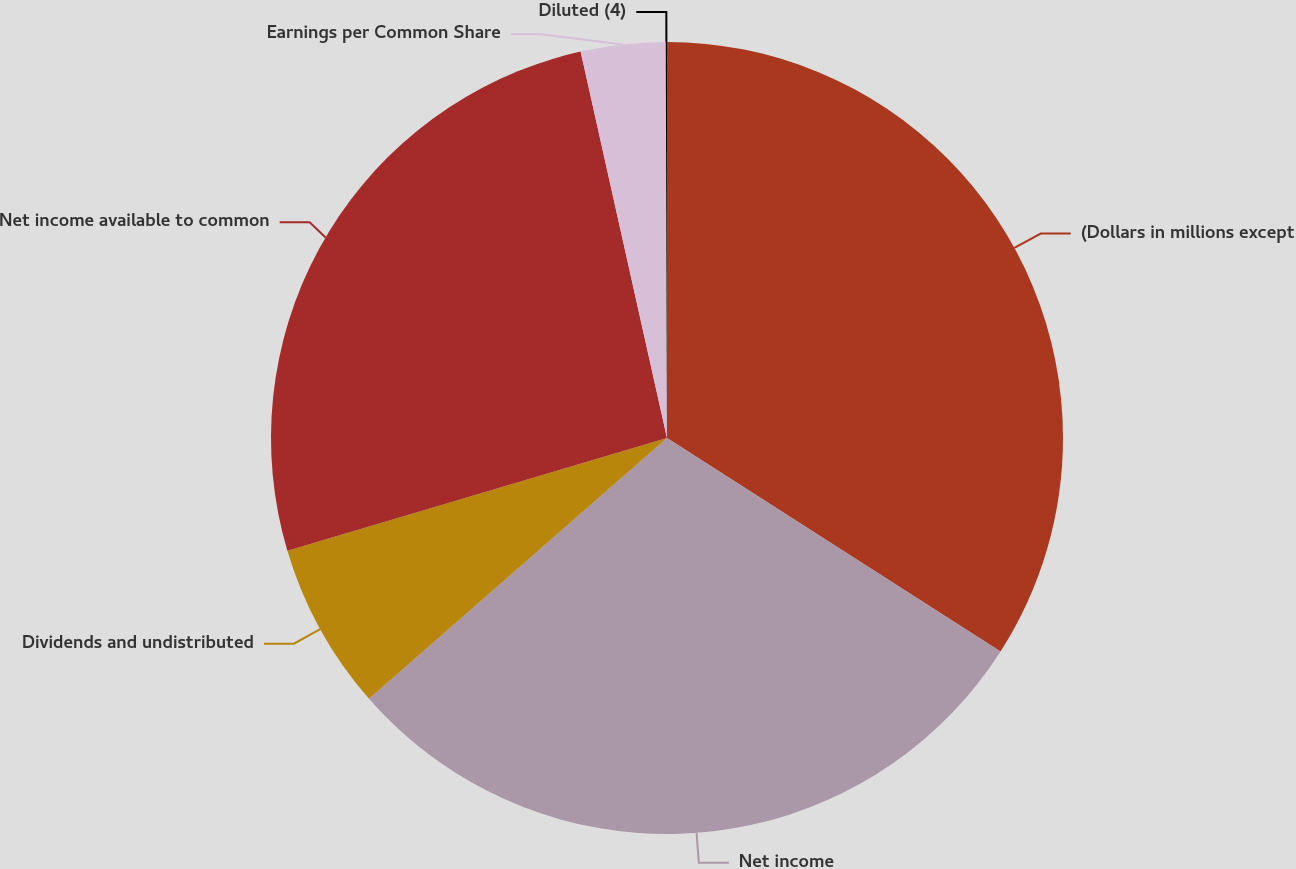Convert chart. <chart><loc_0><loc_0><loc_500><loc_500><pie_chart><fcel>(Dollars in millions except<fcel>Net income<fcel>Dividends and undistributed<fcel>Net income available to common<fcel>Earnings per Common Share<fcel>Diluted (4)<nl><fcel>34.06%<fcel>29.49%<fcel>6.85%<fcel>26.09%<fcel>3.45%<fcel>0.05%<nl></chart> 